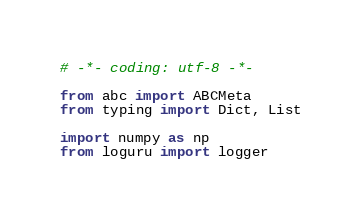<code> <loc_0><loc_0><loc_500><loc_500><_Python_># -*- coding: utf-8 -*-

from abc import ABCMeta
from typing import Dict, List

import numpy as np
from loguru import logger</code> 